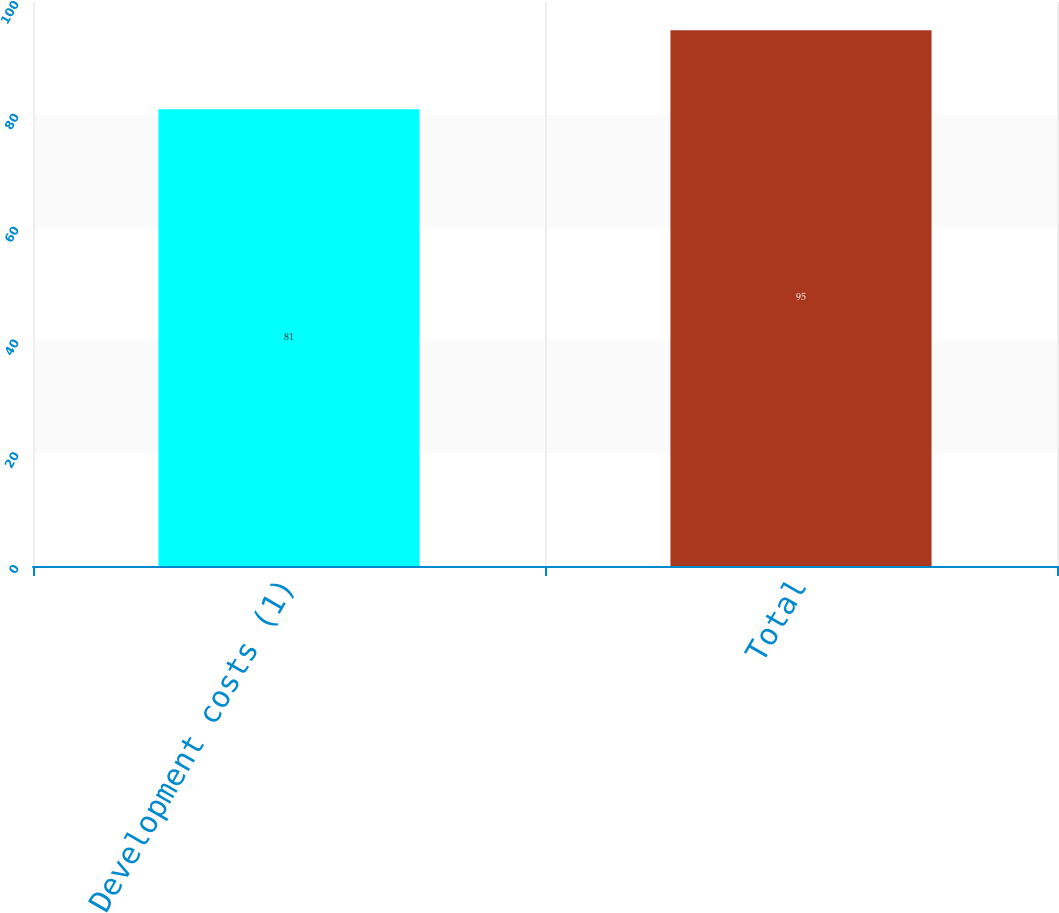<chart> <loc_0><loc_0><loc_500><loc_500><bar_chart><fcel>Development costs (1)<fcel>Total<nl><fcel>81<fcel>95<nl></chart> 